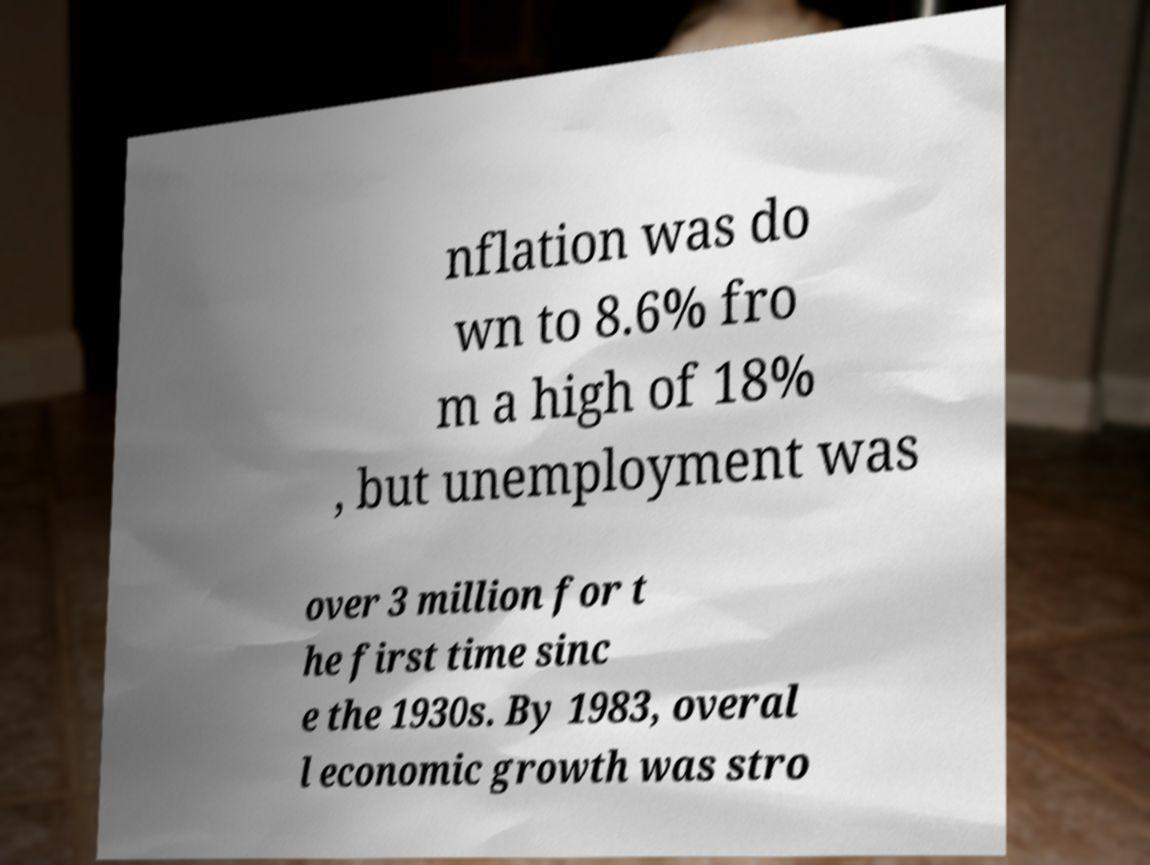Please identify and transcribe the text found in this image. nflation was do wn to 8.6% fro m a high of 18% , but unemployment was over 3 million for t he first time sinc e the 1930s. By 1983, overal l economic growth was stro 